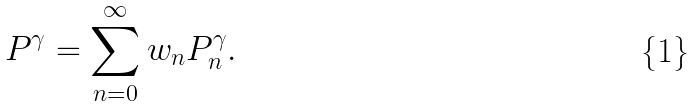<formula> <loc_0><loc_0><loc_500><loc_500>P ^ { \gamma } = \sum _ { n = 0 } ^ { \infty } w _ { n } P ^ { \gamma } _ { n } .</formula> 